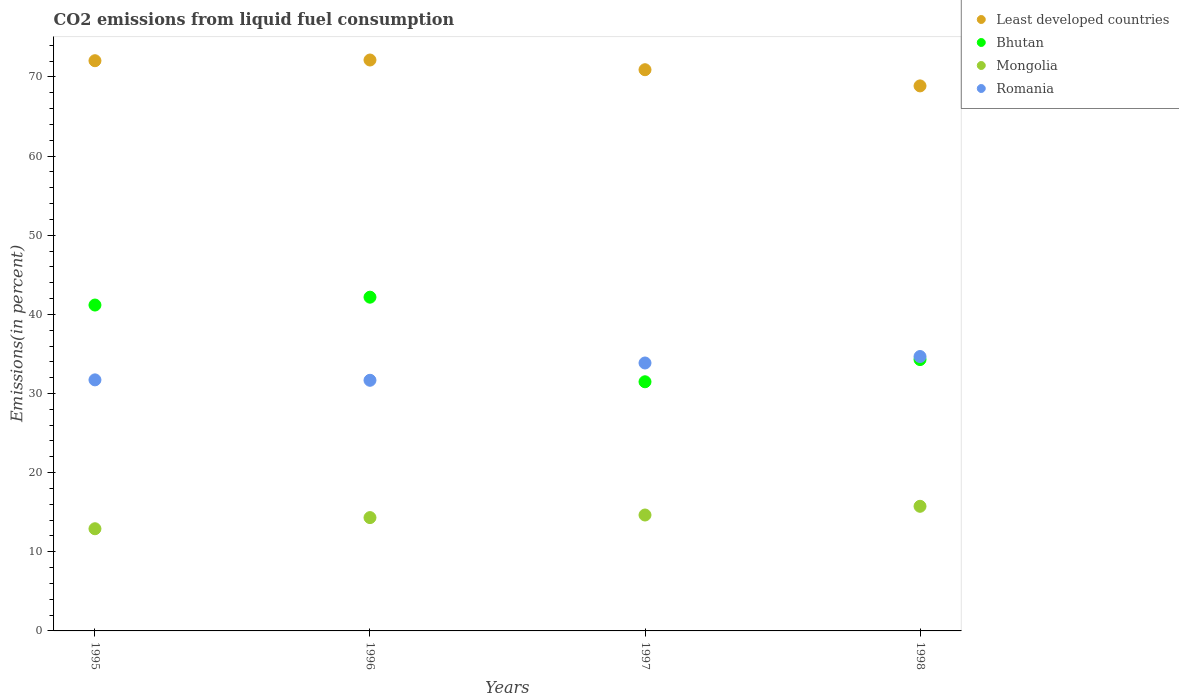How many different coloured dotlines are there?
Ensure brevity in your answer.  4. What is the total CO2 emitted in Least developed countries in 1997?
Your answer should be compact. 70.91. Across all years, what is the maximum total CO2 emitted in Mongolia?
Keep it short and to the point. 15.75. Across all years, what is the minimum total CO2 emitted in Bhutan?
Your answer should be very brief. 31.48. What is the total total CO2 emitted in Least developed countries in the graph?
Your response must be concise. 283.96. What is the difference between the total CO2 emitted in Romania in 1995 and that in 1997?
Provide a succinct answer. -2.13. What is the difference between the total CO2 emitted in Least developed countries in 1998 and the total CO2 emitted in Mongolia in 1995?
Provide a short and direct response. 55.96. What is the average total CO2 emitted in Romania per year?
Offer a terse response. 32.98. In the year 1998, what is the difference between the total CO2 emitted in Bhutan and total CO2 emitted in Least developed countries?
Ensure brevity in your answer.  -34.58. In how many years, is the total CO2 emitted in Romania greater than 42 %?
Your response must be concise. 0. What is the ratio of the total CO2 emitted in Romania in 1995 to that in 1997?
Provide a short and direct response. 0.94. What is the difference between the highest and the second highest total CO2 emitted in Mongolia?
Ensure brevity in your answer.  1.1. What is the difference between the highest and the lowest total CO2 emitted in Bhutan?
Offer a very short reply. 10.69. Is it the case that in every year, the sum of the total CO2 emitted in Bhutan and total CO2 emitted in Least developed countries  is greater than the sum of total CO2 emitted in Romania and total CO2 emitted in Mongolia?
Your answer should be very brief. No. Is the total CO2 emitted in Mongolia strictly less than the total CO2 emitted in Least developed countries over the years?
Give a very brief answer. Yes. How many years are there in the graph?
Your answer should be very brief. 4. Are the values on the major ticks of Y-axis written in scientific E-notation?
Your answer should be compact. No. Does the graph contain any zero values?
Offer a very short reply. No. Does the graph contain grids?
Your answer should be very brief. No. Where does the legend appear in the graph?
Ensure brevity in your answer.  Top right. What is the title of the graph?
Give a very brief answer. CO2 emissions from liquid fuel consumption. Does "St. Vincent and the Grenadines" appear as one of the legend labels in the graph?
Offer a terse response. No. What is the label or title of the X-axis?
Provide a short and direct response. Years. What is the label or title of the Y-axis?
Ensure brevity in your answer.  Emissions(in percent). What is the Emissions(in percent) in Least developed countries in 1995?
Provide a short and direct response. 72.05. What is the Emissions(in percent) in Bhutan in 1995?
Keep it short and to the point. 41.18. What is the Emissions(in percent) in Mongolia in 1995?
Offer a very short reply. 12.91. What is the Emissions(in percent) of Romania in 1995?
Your response must be concise. 31.72. What is the Emissions(in percent) of Least developed countries in 1996?
Provide a succinct answer. 72.14. What is the Emissions(in percent) in Bhutan in 1996?
Offer a very short reply. 42.17. What is the Emissions(in percent) in Mongolia in 1996?
Keep it short and to the point. 14.32. What is the Emissions(in percent) of Romania in 1996?
Offer a very short reply. 31.67. What is the Emissions(in percent) in Least developed countries in 1997?
Make the answer very short. 70.91. What is the Emissions(in percent) of Bhutan in 1997?
Make the answer very short. 31.48. What is the Emissions(in percent) of Mongolia in 1997?
Give a very brief answer. 14.65. What is the Emissions(in percent) in Romania in 1997?
Ensure brevity in your answer.  33.85. What is the Emissions(in percent) of Least developed countries in 1998?
Provide a short and direct response. 68.87. What is the Emissions(in percent) in Bhutan in 1998?
Give a very brief answer. 34.29. What is the Emissions(in percent) in Mongolia in 1998?
Keep it short and to the point. 15.75. What is the Emissions(in percent) of Romania in 1998?
Provide a short and direct response. 34.67. Across all years, what is the maximum Emissions(in percent) of Least developed countries?
Your answer should be very brief. 72.14. Across all years, what is the maximum Emissions(in percent) of Bhutan?
Give a very brief answer. 42.17. Across all years, what is the maximum Emissions(in percent) in Mongolia?
Offer a very short reply. 15.75. Across all years, what is the maximum Emissions(in percent) in Romania?
Provide a succinct answer. 34.67. Across all years, what is the minimum Emissions(in percent) of Least developed countries?
Your response must be concise. 68.87. Across all years, what is the minimum Emissions(in percent) of Bhutan?
Give a very brief answer. 31.48. Across all years, what is the minimum Emissions(in percent) of Mongolia?
Give a very brief answer. 12.91. Across all years, what is the minimum Emissions(in percent) in Romania?
Your answer should be compact. 31.67. What is the total Emissions(in percent) of Least developed countries in the graph?
Offer a terse response. 283.96. What is the total Emissions(in percent) in Bhutan in the graph?
Keep it short and to the point. 149.11. What is the total Emissions(in percent) of Mongolia in the graph?
Make the answer very short. 57.62. What is the total Emissions(in percent) of Romania in the graph?
Offer a terse response. 131.92. What is the difference between the Emissions(in percent) of Least developed countries in 1995 and that in 1996?
Your answer should be very brief. -0.09. What is the difference between the Emissions(in percent) of Bhutan in 1995 and that in 1996?
Make the answer very short. -0.99. What is the difference between the Emissions(in percent) in Mongolia in 1995 and that in 1996?
Provide a succinct answer. -1.41. What is the difference between the Emissions(in percent) of Romania in 1995 and that in 1996?
Ensure brevity in your answer.  0.05. What is the difference between the Emissions(in percent) in Least developed countries in 1995 and that in 1997?
Your response must be concise. 1.14. What is the difference between the Emissions(in percent) in Bhutan in 1995 and that in 1997?
Provide a short and direct response. 9.7. What is the difference between the Emissions(in percent) in Mongolia in 1995 and that in 1997?
Make the answer very short. -1.74. What is the difference between the Emissions(in percent) of Romania in 1995 and that in 1997?
Keep it short and to the point. -2.13. What is the difference between the Emissions(in percent) in Least developed countries in 1995 and that in 1998?
Offer a terse response. 3.18. What is the difference between the Emissions(in percent) of Bhutan in 1995 and that in 1998?
Keep it short and to the point. 6.89. What is the difference between the Emissions(in percent) of Mongolia in 1995 and that in 1998?
Make the answer very short. -2.84. What is the difference between the Emissions(in percent) of Romania in 1995 and that in 1998?
Ensure brevity in your answer.  -2.95. What is the difference between the Emissions(in percent) of Least developed countries in 1996 and that in 1997?
Provide a short and direct response. 1.23. What is the difference between the Emissions(in percent) of Bhutan in 1996 and that in 1997?
Offer a very short reply. 10.69. What is the difference between the Emissions(in percent) in Mongolia in 1996 and that in 1997?
Give a very brief answer. -0.33. What is the difference between the Emissions(in percent) in Romania in 1996 and that in 1997?
Make the answer very short. -2.19. What is the difference between the Emissions(in percent) of Least developed countries in 1996 and that in 1998?
Your answer should be compact. 3.27. What is the difference between the Emissions(in percent) of Bhutan in 1996 and that in 1998?
Offer a very short reply. 7.88. What is the difference between the Emissions(in percent) of Mongolia in 1996 and that in 1998?
Your response must be concise. -1.43. What is the difference between the Emissions(in percent) of Romania in 1996 and that in 1998?
Your answer should be compact. -3. What is the difference between the Emissions(in percent) of Least developed countries in 1997 and that in 1998?
Give a very brief answer. 2.04. What is the difference between the Emissions(in percent) in Bhutan in 1997 and that in 1998?
Give a very brief answer. -2.8. What is the difference between the Emissions(in percent) in Mongolia in 1997 and that in 1998?
Make the answer very short. -1.1. What is the difference between the Emissions(in percent) in Romania in 1997 and that in 1998?
Keep it short and to the point. -0.82. What is the difference between the Emissions(in percent) of Least developed countries in 1995 and the Emissions(in percent) of Bhutan in 1996?
Keep it short and to the point. 29.88. What is the difference between the Emissions(in percent) of Least developed countries in 1995 and the Emissions(in percent) of Mongolia in 1996?
Ensure brevity in your answer.  57.73. What is the difference between the Emissions(in percent) of Least developed countries in 1995 and the Emissions(in percent) of Romania in 1996?
Your response must be concise. 40.38. What is the difference between the Emissions(in percent) of Bhutan in 1995 and the Emissions(in percent) of Mongolia in 1996?
Keep it short and to the point. 26.86. What is the difference between the Emissions(in percent) in Bhutan in 1995 and the Emissions(in percent) in Romania in 1996?
Ensure brevity in your answer.  9.51. What is the difference between the Emissions(in percent) in Mongolia in 1995 and the Emissions(in percent) in Romania in 1996?
Ensure brevity in your answer.  -18.76. What is the difference between the Emissions(in percent) in Least developed countries in 1995 and the Emissions(in percent) in Bhutan in 1997?
Your response must be concise. 40.57. What is the difference between the Emissions(in percent) of Least developed countries in 1995 and the Emissions(in percent) of Mongolia in 1997?
Your response must be concise. 57.4. What is the difference between the Emissions(in percent) of Least developed countries in 1995 and the Emissions(in percent) of Romania in 1997?
Your answer should be compact. 38.19. What is the difference between the Emissions(in percent) of Bhutan in 1995 and the Emissions(in percent) of Mongolia in 1997?
Ensure brevity in your answer.  26.53. What is the difference between the Emissions(in percent) of Bhutan in 1995 and the Emissions(in percent) of Romania in 1997?
Offer a terse response. 7.32. What is the difference between the Emissions(in percent) in Mongolia in 1995 and the Emissions(in percent) in Romania in 1997?
Make the answer very short. -20.94. What is the difference between the Emissions(in percent) in Least developed countries in 1995 and the Emissions(in percent) in Bhutan in 1998?
Your answer should be compact. 37.76. What is the difference between the Emissions(in percent) of Least developed countries in 1995 and the Emissions(in percent) of Mongolia in 1998?
Your answer should be compact. 56.3. What is the difference between the Emissions(in percent) of Least developed countries in 1995 and the Emissions(in percent) of Romania in 1998?
Your answer should be very brief. 37.38. What is the difference between the Emissions(in percent) of Bhutan in 1995 and the Emissions(in percent) of Mongolia in 1998?
Your response must be concise. 25.43. What is the difference between the Emissions(in percent) of Bhutan in 1995 and the Emissions(in percent) of Romania in 1998?
Offer a very short reply. 6.51. What is the difference between the Emissions(in percent) of Mongolia in 1995 and the Emissions(in percent) of Romania in 1998?
Your answer should be compact. -21.76. What is the difference between the Emissions(in percent) in Least developed countries in 1996 and the Emissions(in percent) in Bhutan in 1997?
Provide a succinct answer. 40.66. What is the difference between the Emissions(in percent) in Least developed countries in 1996 and the Emissions(in percent) in Mongolia in 1997?
Your response must be concise. 57.49. What is the difference between the Emissions(in percent) of Least developed countries in 1996 and the Emissions(in percent) of Romania in 1997?
Provide a succinct answer. 38.28. What is the difference between the Emissions(in percent) in Bhutan in 1996 and the Emissions(in percent) in Mongolia in 1997?
Offer a very short reply. 27.52. What is the difference between the Emissions(in percent) in Bhutan in 1996 and the Emissions(in percent) in Romania in 1997?
Provide a succinct answer. 8.31. What is the difference between the Emissions(in percent) of Mongolia in 1996 and the Emissions(in percent) of Romania in 1997?
Ensure brevity in your answer.  -19.54. What is the difference between the Emissions(in percent) in Least developed countries in 1996 and the Emissions(in percent) in Bhutan in 1998?
Give a very brief answer. 37.85. What is the difference between the Emissions(in percent) in Least developed countries in 1996 and the Emissions(in percent) in Mongolia in 1998?
Provide a short and direct response. 56.39. What is the difference between the Emissions(in percent) of Least developed countries in 1996 and the Emissions(in percent) of Romania in 1998?
Provide a succinct answer. 37.47. What is the difference between the Emissions(in percent) in Bhutan in 1996 and the Emissions(in percent) in Mongolia in 1998?
Offer a very short reply. 26.42. What is the difference between the Emissions(in percent) of Bhutan in 1996 and the Emissions(in percent) of Romania in 1998?
Give a very brief answer. 7.5. What is the difference between the Emissions(in percent) of Mongolia in 1996 and the Emissions(in percent) of Romania in 1998?
Ensure brevity in your answer.  -20.35. What is the difference between the Emissions(in percent) in Least developed countries in 1997 and the Emissions(in percent) in Bhutan in 1998?
Your response must be concise. 36.62. What is the difference between the Emissions(in percent) of Least developed countries in 1997 and the Emissions(in percent) of Mongolia in 1998?
Keep it short and to the point. 55.16. What is the difference between the Emissions(in percent) in Least developed countries in 1997 and the Emissions(in percent) in Romania in 1998?
Provide a succinct answer. 36.24. What is the difference between the Emissions(in percent) of Bhutan in 1997 and the Emissions(in percent) of Mongolia in 1998?
Your answer should be compact. 15.73. What is the difference between the Emissions(in percent) in Bhutan in 1997 and the Emissions(in percent) in Romania in 1998?
Your response must be concise. -3.19. What is the difference between the Emissions(in percent) of Mongolia in 1997 and the Emissions(in percent) of Romania in 1998?
Your response must be concise. -20.03. What is the average Emissions(in percent) in Least developed countries per year?
Provide a short and direct response. 70.99. What is the average Emissions(in percent) of Bhutan per year?
Keep it short and to the point. 37.28. What is the average Emissions(in percent) of Mongolia per year?
Your response must be concise. 14.41. What is the average Emissions(in percent) in Romania per year?
Your response must be concise. 32.98. In the year 1995, what is the difference between the Emissions(in percent) of Least developed countries and Emissions(in percent) of Bhutan?
Your answer should be very brief. 30.87. In the year 1995, what is the difference between the Emissions(in percent) of Least developed countries and Emissions(in percent) of Mongolia?
Provide a succinct answer. 59.14. In the year 1995, what is the difference between the Emissions(in percent) in Least developed countries and Emissions(in percent) in Romania?
Keep it short and to the point. 40.33. In the year 1995, what is the difference between the Emissions(in percent) of Bhutan and Emissions(in percent) of Mongolia?
Make the answer very short. 28.27. In the year 1995, what is the difference between the Emissions(in percent) in Bhutan and Emissions(in percent) in Romania?
Give a very brief answer. 9.45. In the year 1995, what is the difference between the Emissions(in percent) of Mongolia and Emissions(in percent) of Romania?
Keep it short and to the point. -18.81. In the year 1996, what is the difference between the Emissions(in percent) of Least developed countries and Emissions(in percent) of Bhutan?
Your answer should be compact. 29.97. In the year 1996, what is the difference between the Emissions(in percent) in Least developed countries and Emissions(in percent) in Mongolia?
Offer a very short reply. 57.82. In the year 1996, what is the difference between the Emissions(in percent) in Least developed countries and Emissions(in percent) in Romania?
Provide a succinct answer. 40.47. In the year 1996, what is the difference between the Emissions(in percent) in Bhutan and Emissions(in percent) in Mongolia?
Give a very brief answer. 27.85. In the year 1996, what is the difference between the Emissions(in percent) in Bhutan and Emissions(in percent) in Romania?
Offer a very short reply. 10.5. In the year 1996, what is the difference between the Emissions(in percent) of Mongolia and Emissions(in percent) of Romania?
Provide a succinct answer. -17.35. In the year 1997, what is the difference between the Emissions(in percent) in Least developed countries and Emissions(in percent) in Bhutan?
Your answer should be very brief. 39.43. In the year 1997, what is the difference between the Emissions(in percent) of Least developed countries and Emissions(in percent) of Mongolia?
Your answer should be compact. 56.26. In the year 1997, what is the difference between the Emissions(in percent) of Least developed countries and Emissions(in percent) of Romania?
Your response must be concise. 37.06. In the year 1997, what is the difference between the Emissions(in percent) in Bhutan and Emissions(in percent) in Mongolia?
Make the answer very short. 16.84. In the year 1997, what is the difference between the Emissions(in percent) of Bhutan and Emissions(in percent) of Romania?
Keep it short and to the point. -2.37. In the year 1997, what is the difference between the Emissions(in percent) of Mongolia and Emissions(in percent) of Romania?
Make the answer very short. -19.21. In the year 1998, what is the difference between the Emissions(in percent) of Least developed countries and Emissions(in percent) of Bhutan?
Your answer should be very brief. 34.58. In the year 1998, what is the difference between the Emissions(in percent) of Least developed countries and Emissions(in percent) of Mongolia?
Your answer should be very brief. 53.12. In the year 1998, what is the difference between the Emissions(in percent) in Least developed countries and Emissions(in percent) in Romania?
Provide a succinct answer. 34.2. In the year 1998, what is the difference between the Emissions(in percent) of Bhutan and Emissions(in percent) of Mongolia?
Keep it short and to the point. 18.54. In the year 1998, what is the difference between the Emissions(in percent) of Bhutan and Emissions(in percent) of Romania?
Provide a succinct answer. -0.39. In the year 1998, what is the difference between the Emissions(in percent) in Mongolia and Emissions(in percent) in Romania?
Give a very brief answer. -18.92. What is the ratio of the Emissions(in percent) in Bhutan in 1995 to that in 1996?
Ensure brevity in your answer.  0.98. What is the ratio of the Emissions(in percent) in Mongolia in 1995 to that in 1996?
Offer a terse response. 0.9. What is the ratio of the Emissions(in percent) of Romania in 1995 to that in 1996?
Ensure brevity in your answer.  1. What is the ratio of the Emissions(in percent) of Bhutan in 1995 to that in 1997?
Offer a very short reply. 1.31. What is the ratio of the Emissions(in percent) in Mongolia in 1995 to that in 1997?
Make the answer very short. 0.88. What is the ratio of the Emissions(in percent) in Romania in 1995 to that in 1997?
Your response must be concise. 0.94. What is the ratio of the Emissions(in percent) of Least developed countries in 1995 to that in 1998?
Make the answer very short. 1.05. What is the ratio of the Emissions(in percent) of Bhutan in 1995 to that in 1998?
Your answer should be very brief. 1.2. What is the ratio of the Emissions(in percent) of Mongolia in 1995 to that in 1998?
Your answer should be very brief. 0.82. What is the ratio of the Emissions(in percent) of Romania in 1995 to that in 1998?
Give a very brief answer. 0.91. What is the ratio of the Emissions(in percent) of Least developed countries in 1996 to that in 1997?
Ensure brevity in your answer.  1.02. What is the ratio of the Emissions(in percent) in Bhutan in 1996 to that in 1997?
Ensure brevity in your answer.  1.34. What is the ratio of the Emissions(in percent) in Mongolia in 1996 to that in 1997?
Your answer should be very brief. 0.98. What is the ratio of the Emissions(in percent) in Romania in 1996 to that in 1997?
Give a very brief answer. 0.94. What is the ratio of the Emissions(in percent) of Least developed countries in 1996 to that in 1998?
Offer a very short reply. 1.05. What is the ratio of the Emissions(in percent) in Bhutan in 1996 to that in 1998?
Provide a succinct answer. 1.23. What is the ratio of the Emissions(in percent) of Mongolia in 1996 to that in 1998?
Offer a very short reply. 0.91. What is the ratio of the Emissions(in percent) of Romania in 1996 to that in 1998?
Make the answer very short. 0.91. What is the ratio of the Emissions(in percent) of Least developed countries in 1997 to that in 1998?
Keep it short and to the point. 1.03. What is the ratio of the Emissions(in percent) of Bhutan in 1997 to that in 1998?
Give a very brief answer. 0.92. What is the ratio of the Emissions(in percent) of Mongolia in 1997 to that in 1998?
Keep it short and to the point. 0.93. What is the ratio of the Emissions(in percent) of Romania in 1997 to that in 1998?
Provide a short and direct response. 0.98. What is the difference between the highest and the second highest Emissions(in percent) of Least developed countries?
Ensure brevity in your answer.  0.09. What is the difference between the highest and the second highest Emissions(in percent) of Mongolia?
Your answer should be compact. 1.1. What is the difference between the highest and the second highest Emissions(in percent) in Romania?
Your answer should be compact. 0.82. What is the difference between the highest and the lowest Emissions(in percent) of Least developed countries?
Ensure brevity in your answer.  3.27. What is the difference between the highest and the lowest Emissions(in percent) in Bhutan?
Provide a short and direct response. 10.69. What is the difference between the highest and the lowest Emissions(in percent) of Mongolia?
Your answer should be compact. 2.84. What is the difference between the highest and the lowest Emissions(in percent) in Romania?
Keep it short and to the point. 3. 